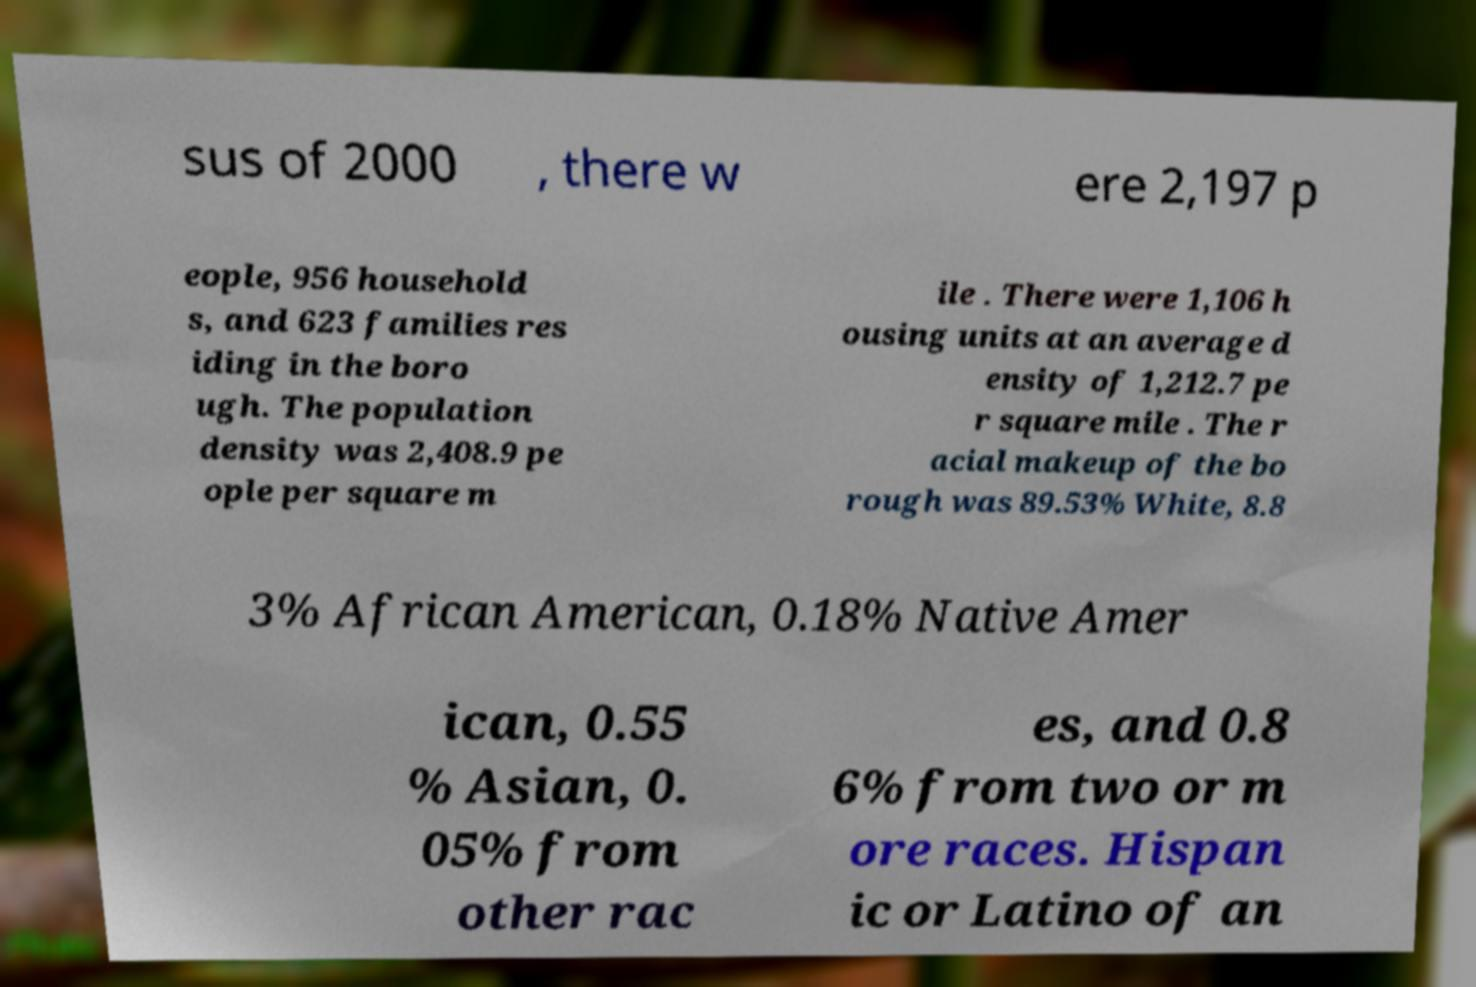Can you read and provide the text displayed in the image?This photo seems to have some interesting text. Can you extract and type it out for me? sus of 2000 , there w ere 2,197 p eople, 956 household s, and 623 families res iding in the boro ugh. The population density was 2,408.9 pe ople per square m ile . There were 1,106 h ousing units at an average d ensity of 1,212.7 pe r square mile . The r acial makeup of the bo rough was 89.53% White, 8.8 3% African American, 0.18% Native Amer ican, 0.55 % Asian, 0. 05% from other rac es, and 0.8 6% from two or m ore races. Hispan ic or Latino of an 